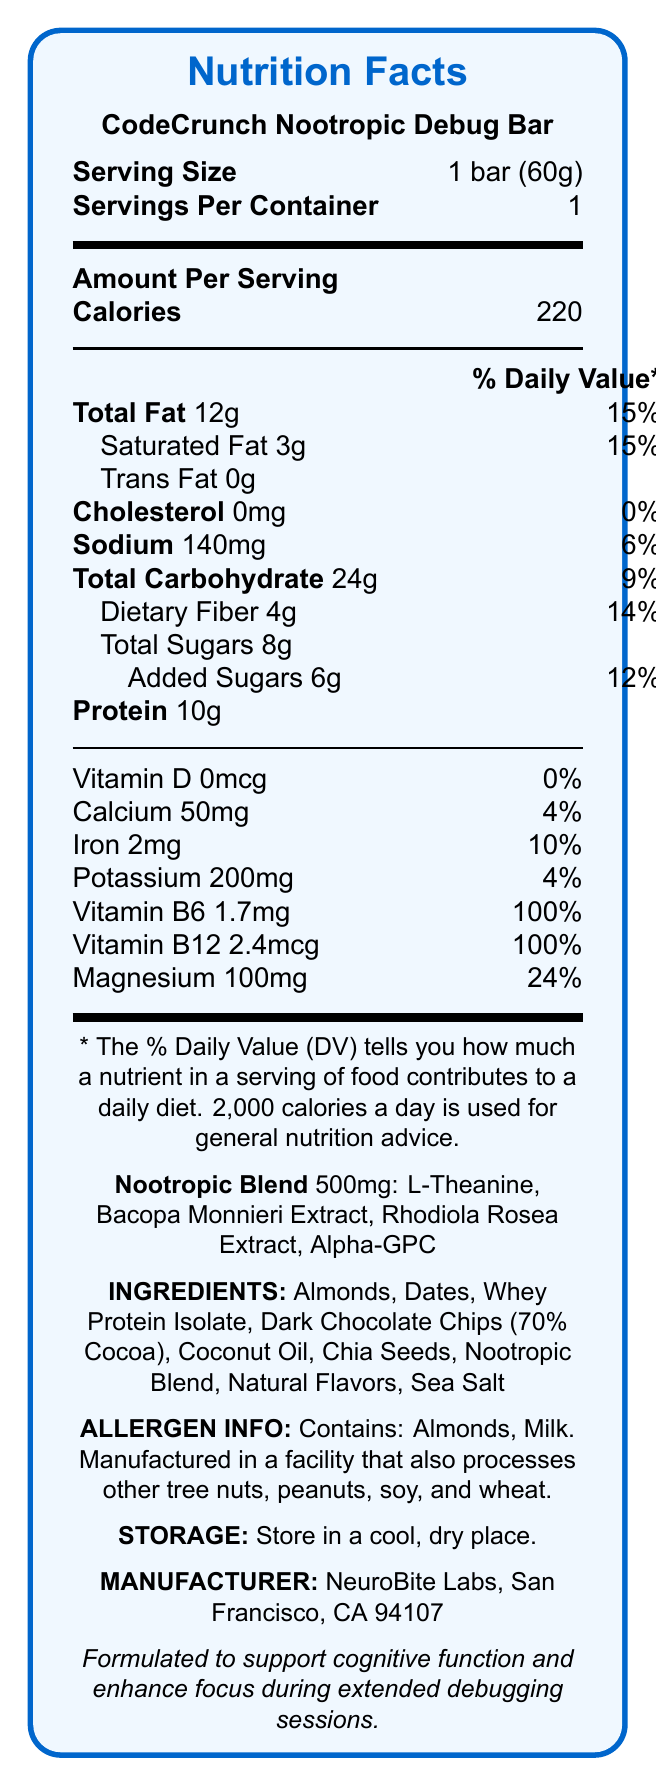What is the serving size of the CodeCrunch Nootropic Debug Bar? The serving size is directly stated in the Nutrition Facts under "Serving Size".
Answer: 1 bar (60g) How many calories are there per serving? The amount of calories per serving is explicitly mentioned as 220 in the "Amount Per Serving" section.
Answer: 220 What is the total weight of the nootropic blend in the bar? The weight of the nootropic blend is specified as 500mg in the "Nootropic Blend" section.
Answer: 500mg How much protein does the CodeCrunch Nootropic Debug Bar contain? The protein content is given as 10g in the Nutrition Facts under "Protein".
Answer: 10g Does this product contain any trans fat? The document specifies "Trans Fat 0g", which means there is no trans fat in the product.
Answer: No Which of the following ingredients is not part of the nootropic blend in the bar? A. L-Theanine B. Bacopa Monnieri Extract C. Dark Chocolate Chips D. Alpha-GPC The nootropic blend includes L-Theanine, Bacopa Monnieri Extract, Rhodiola Rosea Extract, and Alpha-GPC, but not Dark Chocolate Chips. This ingredient is listed separately in the "INGREDIENTS" section.
Answer: C. Dark Chocolate Chips Which vitamin in the bar has a daily value percentage of 100%? 1. Vitamin D 2. Vitamin B6 3. Calcium 4. Magnesium The Nutrition Facts state that Vitamin B6 has a 100% daily value percentage.
Answer: 2. Vitamin B6 Does the CodeCrunch Nootropic Debug Bar contain any allergens? The allergen information section states that the bar contains almonds and milk and is manufactured in a facility that processes other allergens.
Answer: Yes Describe the key nutritional aspects and benefits of the CodeCrunch Nootropic Debug Bar. The detailed explanation includes the calorie content, macronutrients, key vitamins, dietary considerations, and the purpose of the bar (to enhance focus during debugging).
Answer: The CodeCrunch Nootropic Debug Bar provides 220 calories per serving, with 12g of total fat (15% DV), 10g of protein, and a blend of nootropic ingredients designed to support cognitive function and focus. It contains 4g of dietary fiber, 8g of sugars (including 6g of added sugars), and vital vitamins like Vitamin B6 and B12, which are at 100% of the daily value. The bar is formulated to assist during extended debugging sessions. What is the address of the manufacturer of the CodeCrunch Nootropic Debug Bar? The address is directly provided in the "MANUFACTURER" section of the document.
Answer: NeuroBite Labs, San Francisco, CA 94107 Does the bar contain any dietary fiber? If so, how much? The document states that the bar contains 4g of dietary fiber in the "Total Carbohydrate" section.
Answer: Yes, 4g Is the sodium content in the bar high compared to the daily value? The sodium content is 140mg, which is 6% of the daily value. This is relatively moderate and not considered high.
Answer: No What are the primary ingredients in the bar aside from the nootropic blend? These ingredients are listed in the "INGREDIENTS" section.
Answer: Almonds, Dates, Whey Protein Isolate, Dark Chocolate Chips (70% Cocoa), Coconut Oil, Chia Seeds, Natural Flavors, Sea Salt Does the product contain vitamin D? The document states that Vitamin D content is 0mcg, which is 0% of the daily value, indicating that the product does not contain vitamin D.
Answer: No What cognitive benefits does the bar claim to provide? This claim is explicitly mentioned at the bottom of the document.
Answer: Supports cognitive function and enhances focus during extended debugging sessions What is the daily value percentage for magnesium in this bar? The document lists the daily value percentage for magnesium as 24%.
Answer: 24% Which ingredient is used in the bar to contribute to the protein content? Whey Protein Isolate is listed as one of the ingredients and is known for its high protein content.
Answer: Whey Protein Isolate What could be a potential concern for someone with nut allergies regarding this bar? The allergen information section highlights the presence of almonds and potential cross-contamination with other allergens.
Answer: The bar contains almonds and is manufactured in a facility that processes other tree nuts, peanuts, soy, and wheat What is the amount of calcium in the bar, and what percentage of the daily value does it represent? The bar contains 50mg of calcium, which represents 4% of the daily value.
Answer: 50mg, 4% What manufacturing company produces the CodeCrunch Nootropic Debug Bar? The manufacturer is stated as NeuroBite Labs, as mentioned in the "MANUFACTURER" section.
Answer: NeuroBite Labs How much added sugar does the bar contain, and is this amount high in relation to the daily value? The bar contains 6g of added sugar, which is 12% of the daily value mentioned in the "Total Sugars" section.
Answer: 6g, 12% 